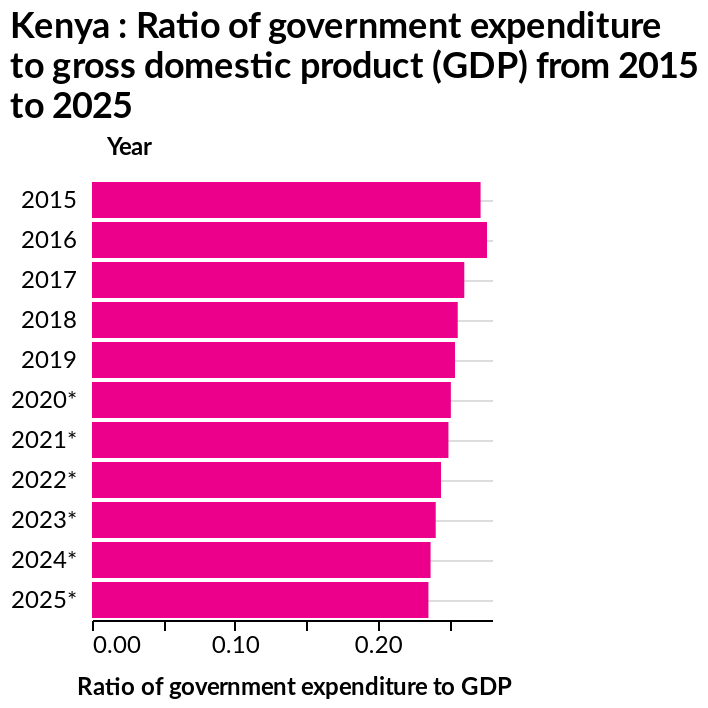<image>
What is the scale used for measuring the x-axis in the bar diagram?  The x-axis in the bar diagram uses a linear scale ranging from 0.00 to 0.25. Can we expect the predicted expenditure to decrease in the future?  Yes, the predicted expenditure is also showing a slight downwards trend. What is the range of the y-axis in the bar diagram?  The range of the y-axis in the bar diagram is from 2015 to 2025. 